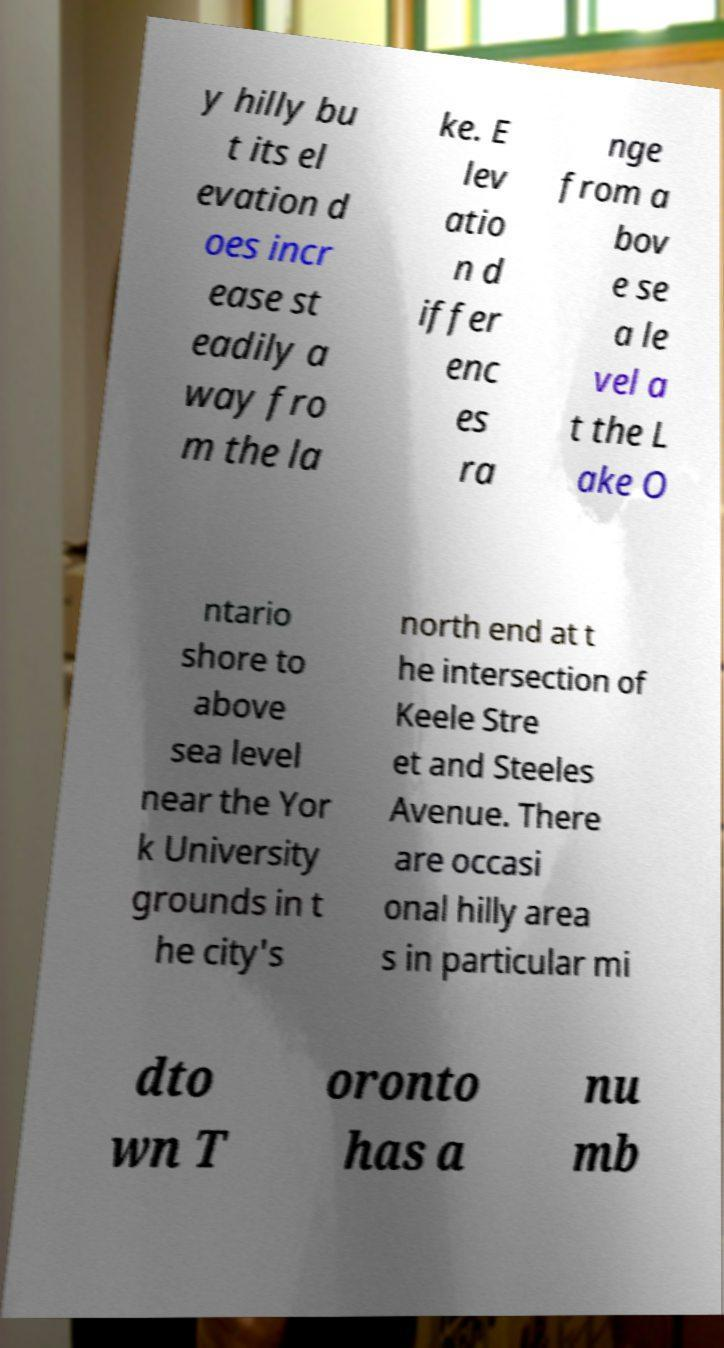Please read and relay the text visible in this image. What does it say? y hilly bu t its el evation d oes incr ease st eadily a way fro m the la ke. E lev atio n d iffer enc es ra nge from a bov e se a le vel a t the L ake O ntario shore to above sea level near the Yor k University grounds in t he city's north end at t he intersection of Keele Stre et and Steeles Avenue. There are occasi onal hilly area s in particular mi dto wn T oronto has a nu mb 